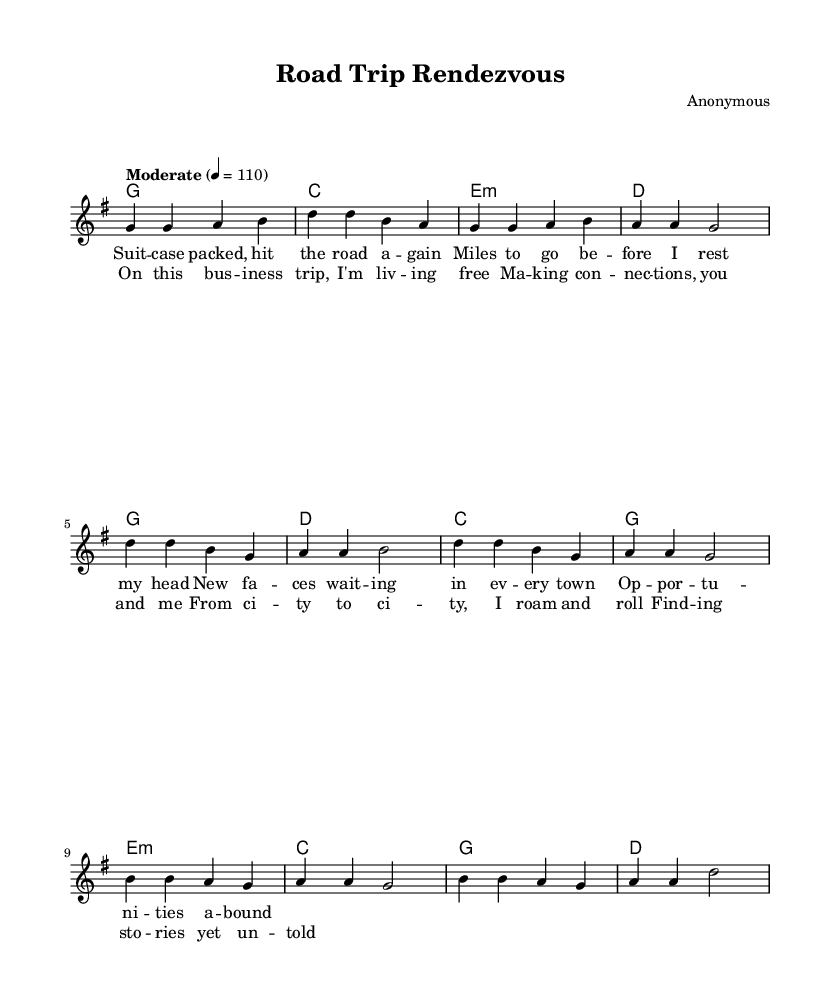What is the key signature of this music? The key signature is G major, which has one sharp (F#).
Answer: G major What is the time signature of this piece? The time signature is four-four, indicated by the 4/4 written at the beginning, meaning there are four beats in each measure.
Answer: 4/4 What is the tempo marking of the song? The tempo marking is "Moderate" with a metronome marking of 110 beats per minute. This indicates the speed at which the music should be played.
Answer: 110 How many measures are in the verse? The verse consists of four measures, as indicated by the notation and counting the segments from the start to the end of the verse section.
Answer: 4 What type of song is this classified as? This song is classified as a country song, based on its themes of traveling and meeting new people during business trips, which are common in country music.
Answer: Country What is the function of the chorus in this song? The function of the chorus is to summarize the main ideas, providing a catchy and repetitive section that emphasizes the experiences of making connections while traveling.
Answer: Summary Which harmony chord appears in the bridge? The harmony chord present in the bridge is E minor, as indicated by the chord symbols below the melody that represent the harmony at that section.
Answer: E minor 